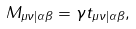Convert formula to latex. <formula><loc_0><loc_0><loc_500><loc_500>M _ { \mu \nu | \alpha \beta } = \gamma t _ { \mu \nu | \alpha \beta } ,</formula> 